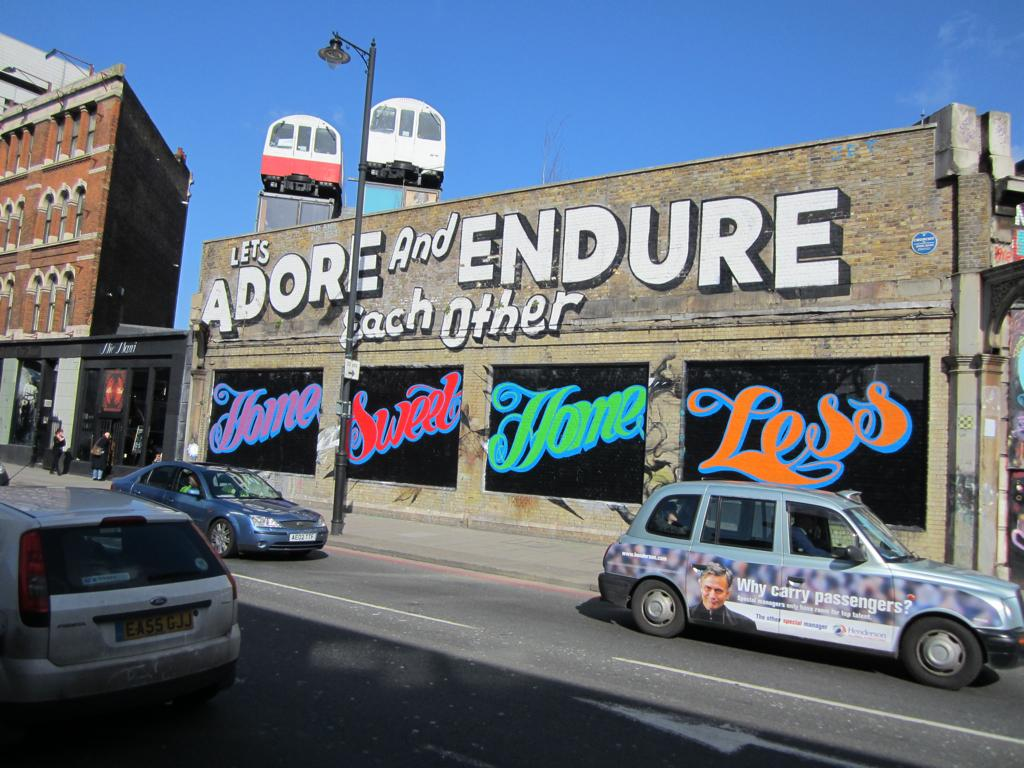<image>
Describe the image concisely. The outside of a store that says Let's Adore and Endure Each other with cars going by. 